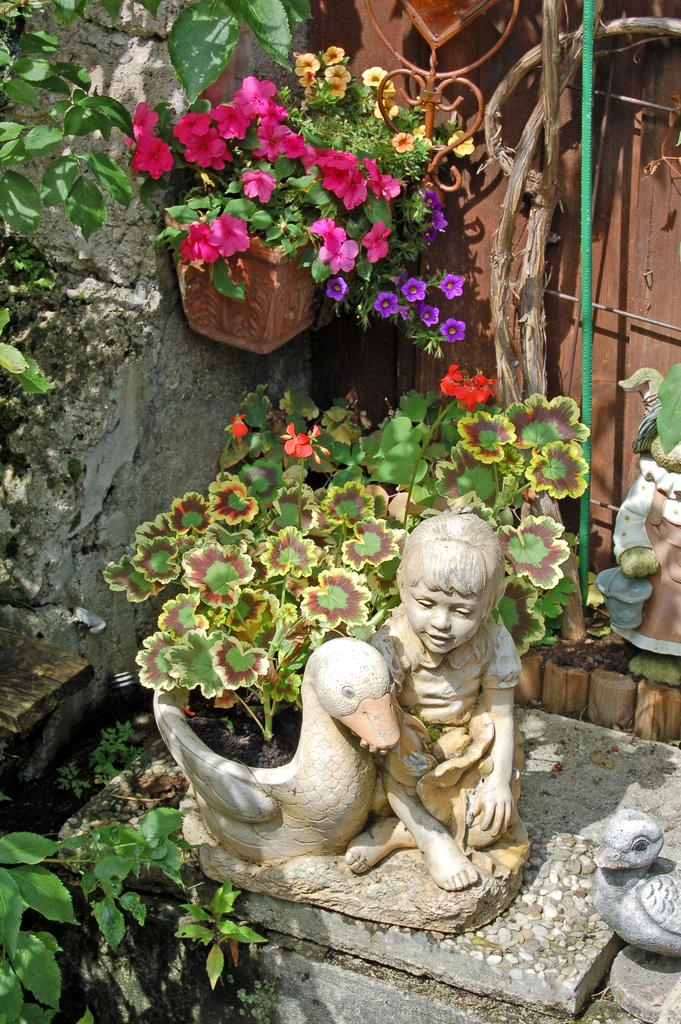What is the main subject in the middle of the image? There is a statue of a child in the middle of the image. Can you describe any other objects or elements in the image? Yes, there is a plant in the bottom left corner of the image. How many arms does the table have in the image? There is no table present in the image, so it is not possible to determine the number of arms it might have. 